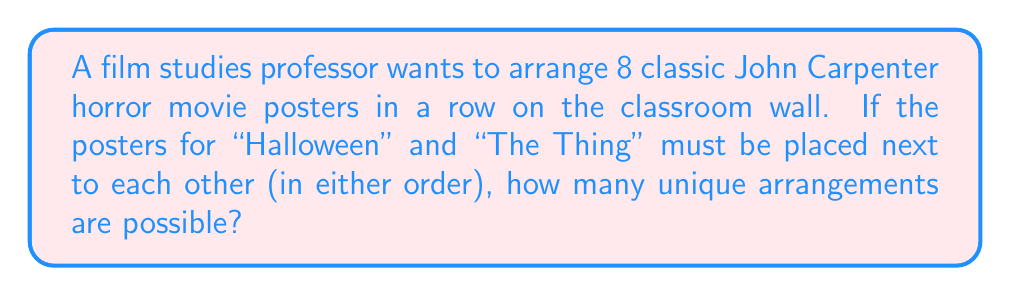Teach me how to tackle this problem. Let's approach this step-by-step:

1) First, consider "Halloween" and "The Thing" posters as a single unit. This means we now have 7 units to arrange (6 individual posters + 1 unit of "Halloween" and "The Thing").

2) The number of ways to arrange 7 distinct units is 7!, which is:
   
   $$7! = 7 \times 6 \times 5 \times 4 \times 3 \times 2 \times 1 = 5040$$

3) However, we need to consider that "Halloween" and "The Thing" can be arranged in 2 ways within their unit (Halloween-Thing or Thing-Halloween).

4) By the multiplication principle, we multiply our previous result by 2:

   $$5040 \times 2 = 10080$$

Therefore, there are 10,080 unique ways to arrange the posters under these conditions.
Answer: 10,080 